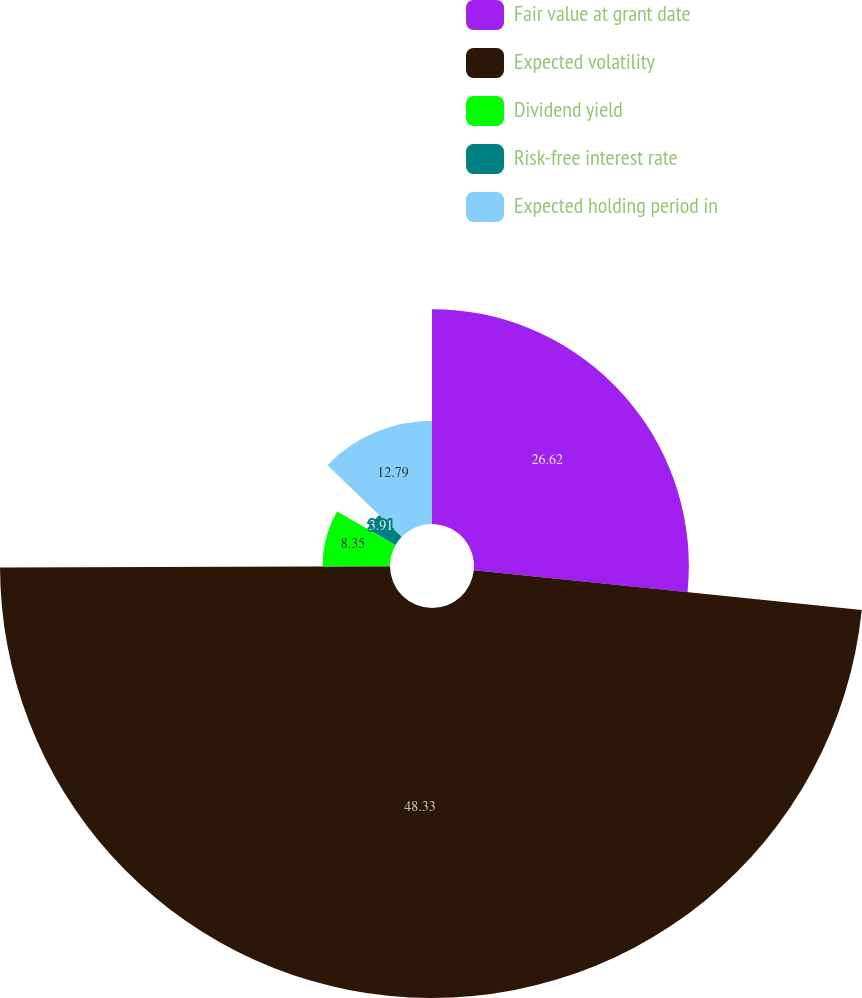Convert chart to OTSL. <chart><loc_0><loc_0><loc_500><loc_500><pie_chart><fcel>Fair value at grant date<fcel>Expected volatility<fcel>Dividend yield<fcel>Risk-free interest rate<fcel>Expected holding period in<nl><fcel>26.62%<fcel>48.32%<fcel>8.35%<fcel>3.91%<fcel>12.79%<nl></chart> 